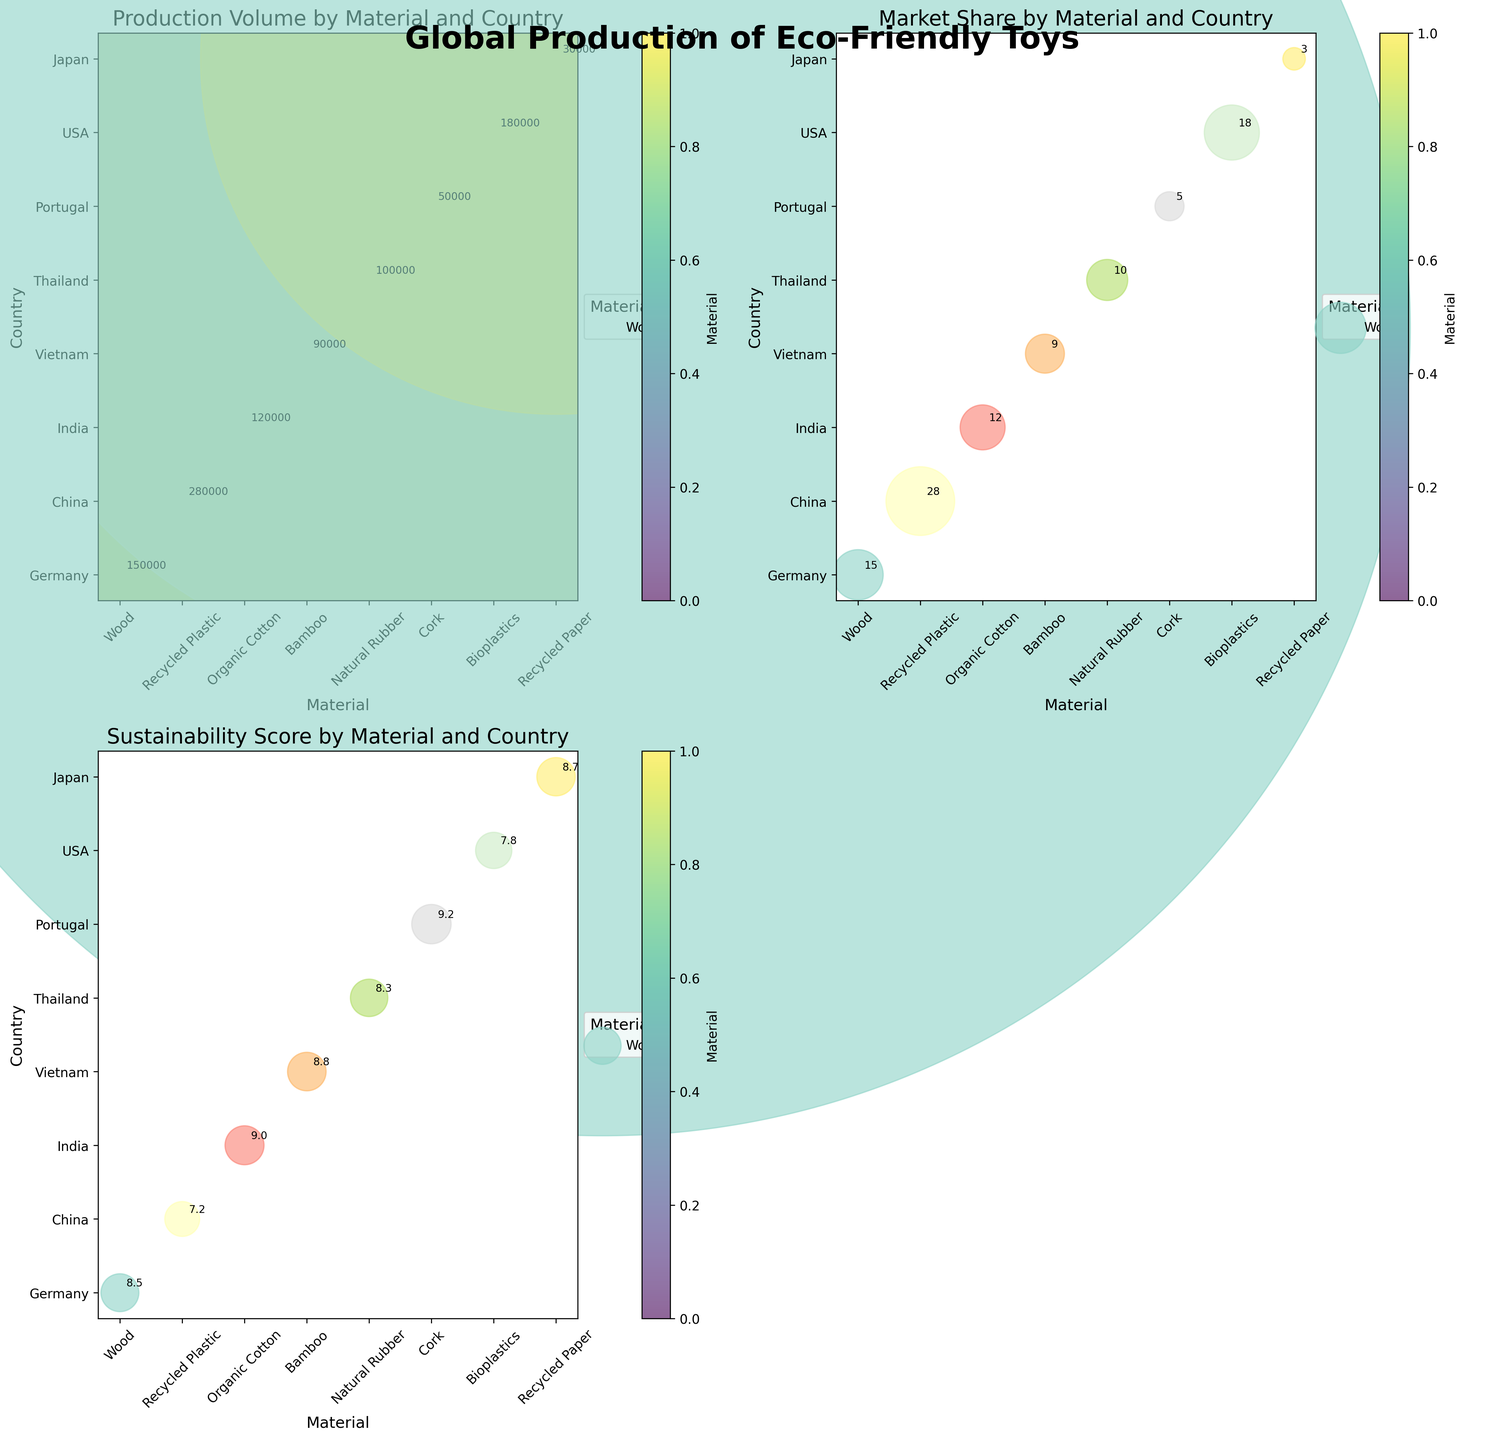What is the title of the figure? The title of the figure is usually positioned at the top of the figure. In this case, it states, "Global Production of Eco-Friendly Toys".
Answer: Global Production of Eco-Friendly Toys Which material has the highest production volume? By looking at the subplot titled "Production Volume by Material and Country" and observing the size of the bubbles, we can see that the largest bubble corresponds to Recycled Plastic from China.
Answer: Recycled Plastic How many subplots are there in the figure? The figure consists of 2x2 subplots, but one of the subplots is not used, making the total effective subplots three.
Answer: 3 What is the sustainability score of Bioplastics? By looking at the subplot titled "Sustainability Score by Material and Country", we can identify the bubble for Bioplastics under USA and check the annotation on it which shows its score.
Answer: 7.8 Which country has the lowest market share for eco-friendly toys? By observing the subplot titled "Market Share by Material and Country" and identifying the smallest bubble, we see that it corresponds to Japan with Recycled Paper.
Answer: Japan Compare the sustainability score of Bamboo and Cork. Which is higher? First, identify Bamboo and Cork in the sustainability score subplot and compare their annotated values. Bamboo has a score of 8.8, while Cork has 9.2.
Answer: Cork What is the difference in production volume between Wood and Bamboo? Wood's production volume is 150,000 and Bamboo's is 90,000. Subtract Bamboo's production volume from Wood's production volume: 150,000 - 90,000 = 60,000.
Answer: 60,000 What are the countries producing toys from Natural Rubber and Organic Cotton? By observing the bubble chart and looking under the Natural Rubber and Organic Cotton categories, we can see the countries are Thailand for Natural Rubber and India for Organic Cotton.
Answer: Thailand and India Which material type has the second highest market share? By looking at the subplot titled "Market Share by Material and Country", we can sort the annotated values and see that the second highest market share is held by Bioplastics from USA with 18%.
Answer: Bioplastics In terms of sustainability, which material ranks highest? Observing the subplot titled "Sustainability Score by Material and Country" and checking the annotated values shows that the highest score is 9.2, which corresponds to Cork from Portugal.
Answer: Cork 